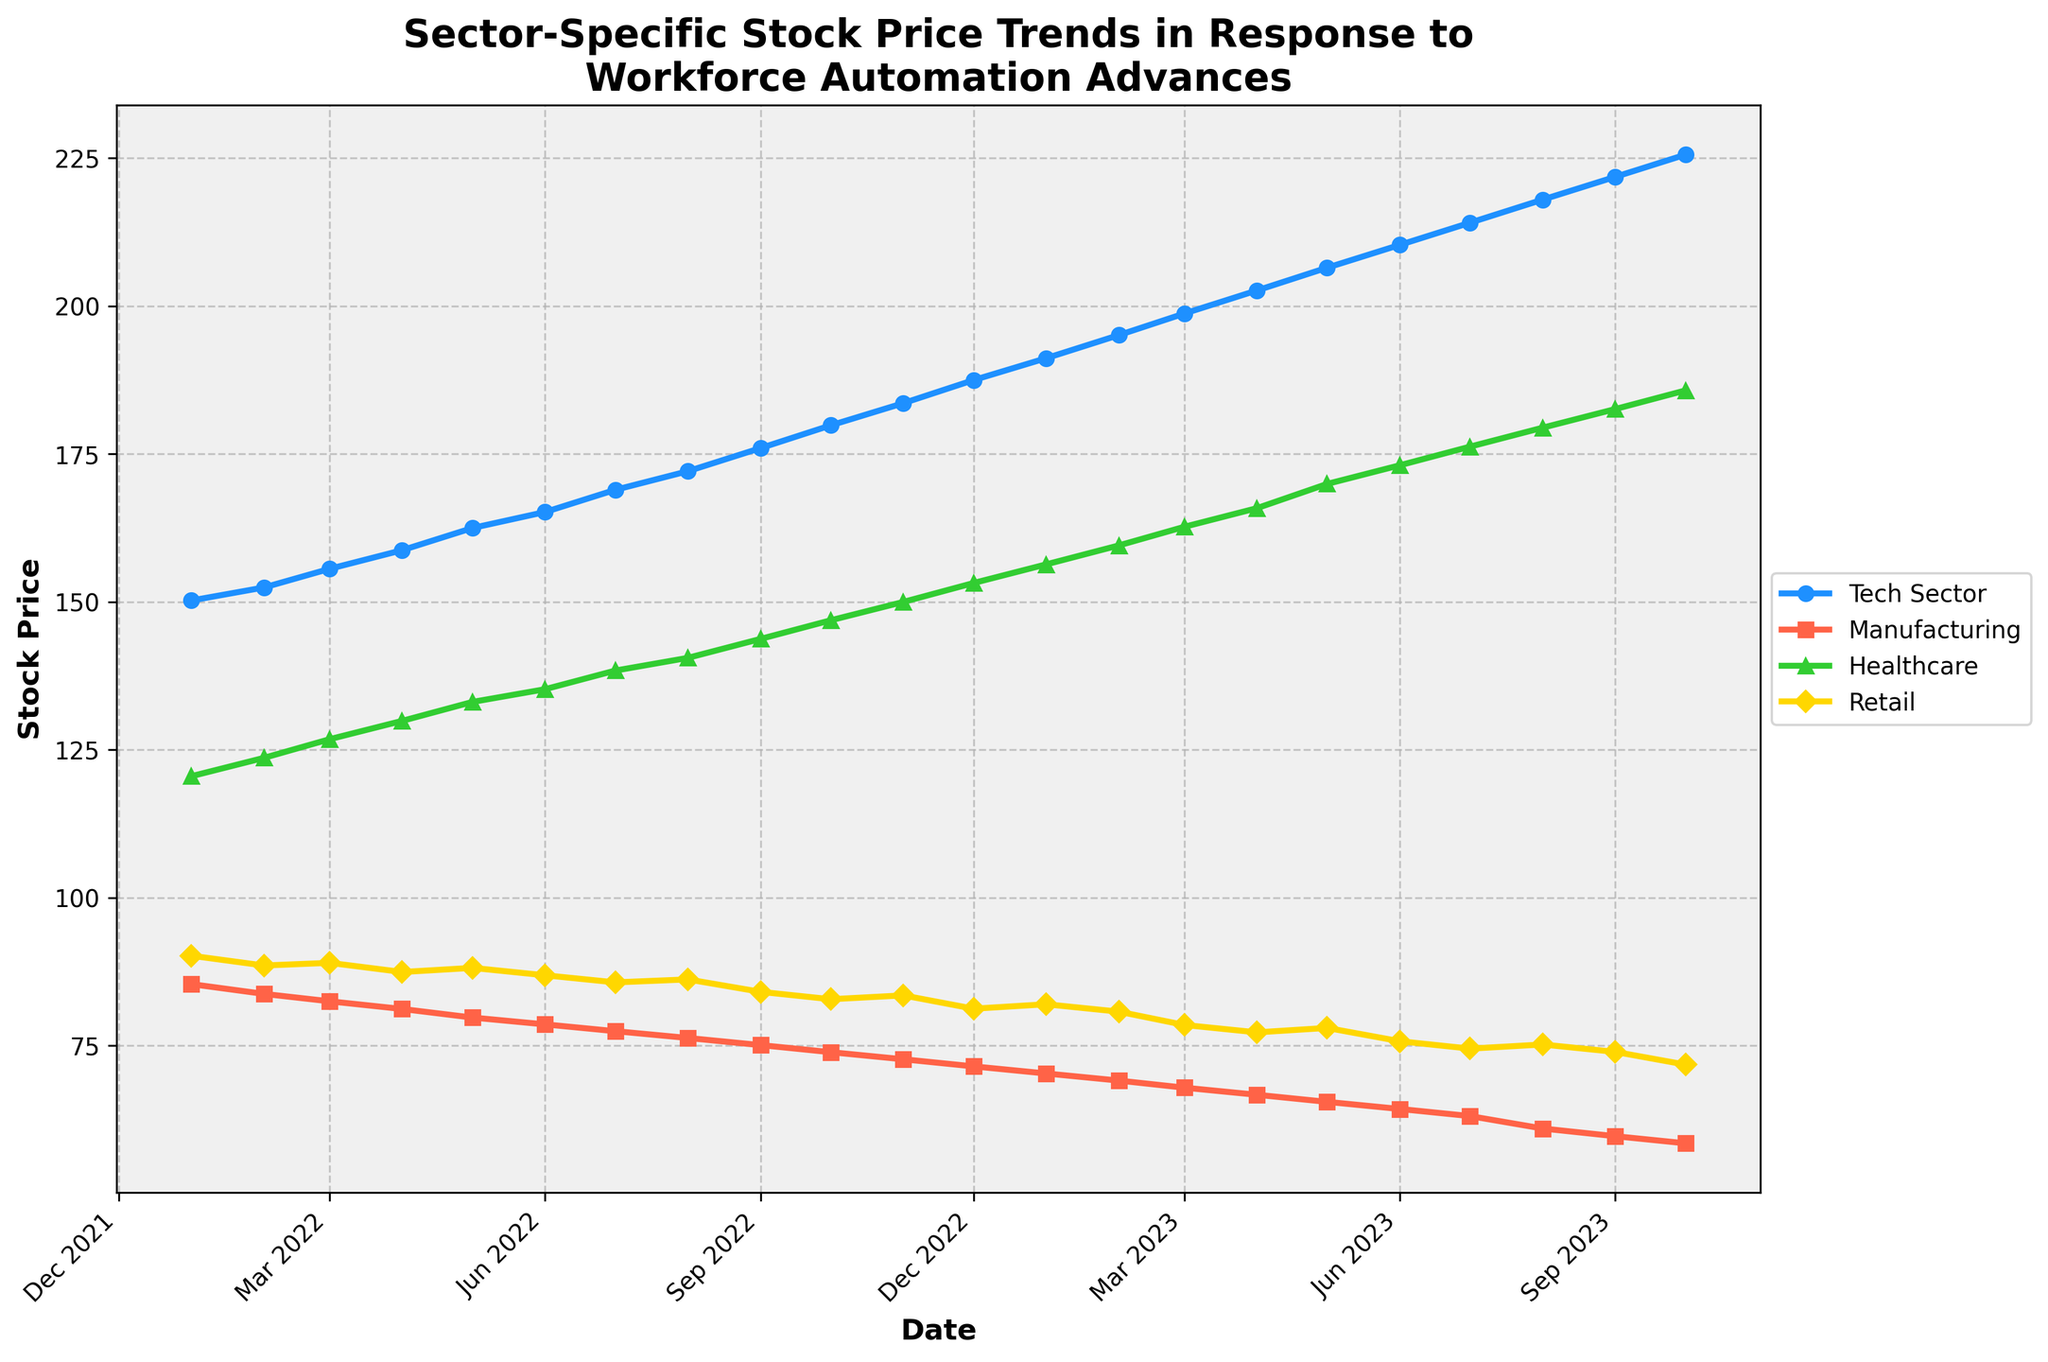What is the title of the plot? The title of the plot is clearly displayed at the top. It reads "Sector-Specific Stock Price Trends in Response to Workforce Automation Advances".
Answer: Sector-Specific Stock Price Trends in Response to Workforce Automation Advances How does the stock price trend for the Tech Sector compare from January 2022 to October 2023? To determine the trend, observe the Tech Sector line from January 2022 to October 2023. The line shows a consistent upward trend starting from around 150.25 in January 2022, reaching 225.60 in October 2023.
Answer: It is consistently increasing Which sector experienced the most significant decline between January 2022 and October 2023? By closely observing the plot, the Manufacturing sector shows a noticeable decline starting from around 85.40 in January 2022 to 58.50 in October 2023. The Tech, Healthcare, and Retail sectors do not show similar declines.
Answer: Manufacturing What is the stock price for the Healthcare sector in May 2023? The Healthcare line indicates the stock price at the intersection of May 2023 on the x-axis. The corresponding y-axis value is approximately 169.95.
Answer: Approximately 169.95 Between which months did the Retail sector experience the most significant drop in stock price? The Retail sector line shows a sharp drop between June 2023 and October 2023, with values dropping from around 75.75 to 71.80.
Answer: June 2023 to October 2023 Which sector showed the highest stock price in October 2023? By comparing the ending points of all four sector lines in October 2023, the Tech Sector had the highest value, around 225.60.
Answer: Tech Sector What is the average stock price of the Manufacturing sector from January 2022 to December 2022? Sum the values of the Manufacturing sector from January 2022 to December 2022 and divide by the number of data points (12): (85.40 + 83.75 + 82.50 + 81.20 + 79.75 + 78.60 + 77.45 + 76.30 + 75.10 + 73.90 + 72.70 + 71.50) / 12 = 78.45.
Answer: 78.45 How did the Healthcare sector perform relative to the Manufacturing sector in March 2023? In March 2023, the Healthcare sector stands at approximately 162.70, while the Manufacturing sector is around 67.90. The Healthcare sector performs significantly better.
Answer: Healthcare sector performed significantly better What can be inferred about the impact of workforce automation on the Tech Sector and Retail sector? The consistent increase in stock prices for the Tech Sector suggests that workforce automation positively affected it. In contrast, the Retail sector shows more fluctuation, with some decline periods indicating mixed impacts.
Answer: Tech positively affected; Retail mixed impacts Which month witnessed the highest growth rate in the Tech Sector? Observe the steepest slope in the Tech Sector line, which seems to be between July 2023 and August 2023, with an increase from approximately 214.10 to 218.00.
Answer: Between July 2023 and August 2023 